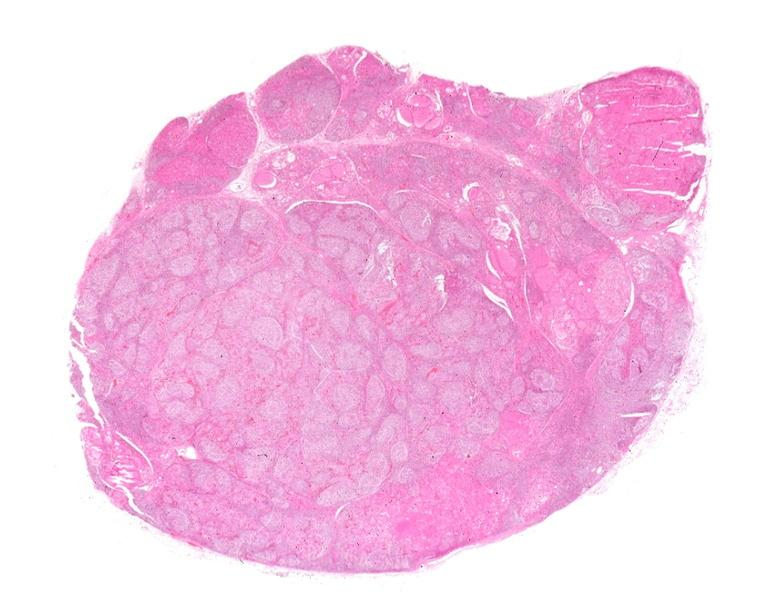s endocrine present?
Answer the question using a single word or phrase. Yes 